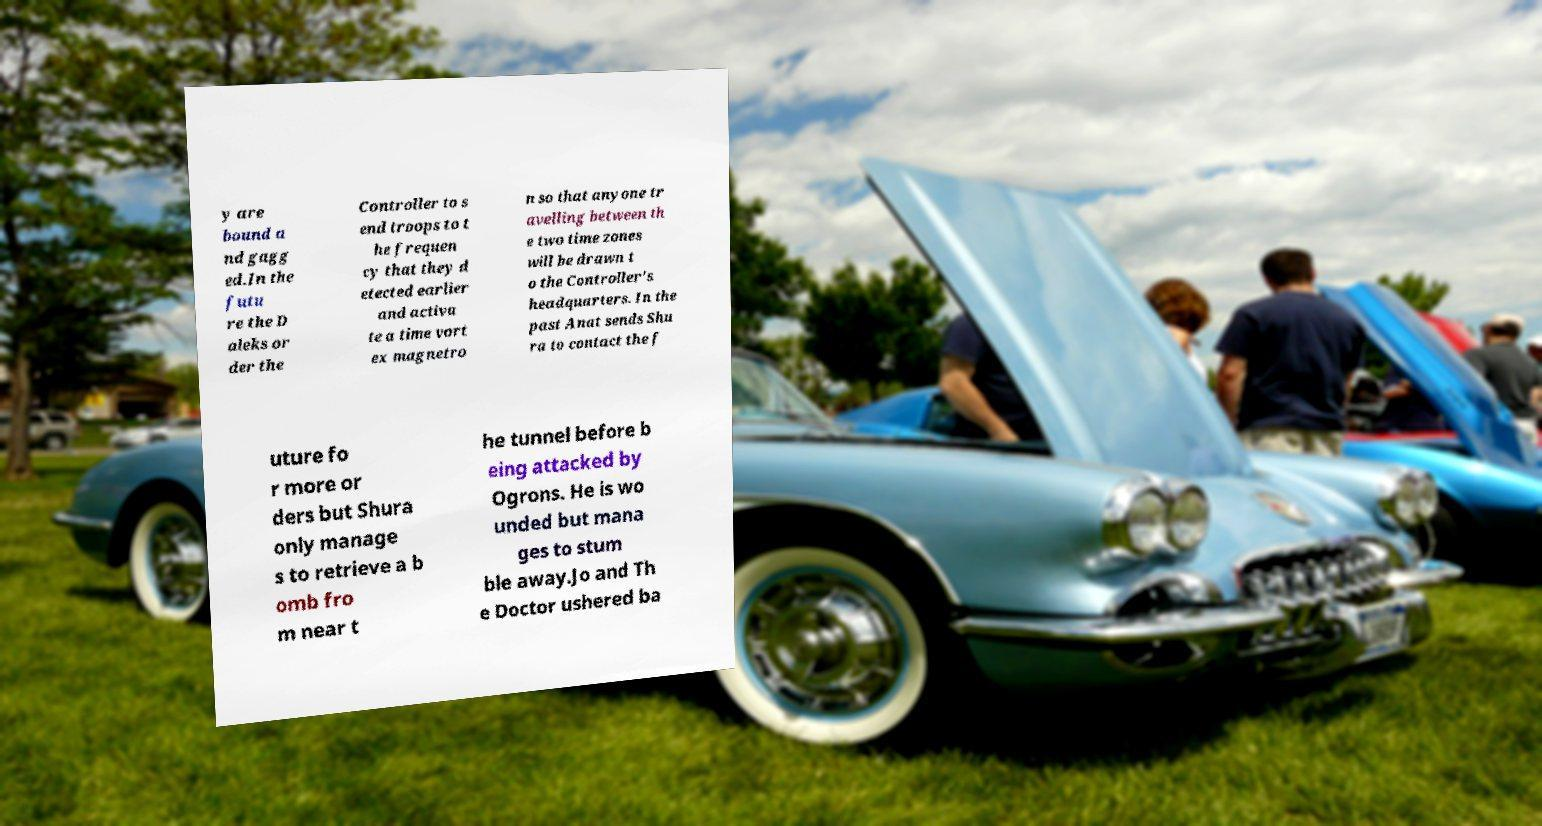What messages or text are displayed in this image? I need them in a readable, typed format. y are bound a nd gagg ed.In the futu re the D aleks or der the Controller to s end troops to t he frequen cy that they d etected earlier and activa te a time vort ex magnetro n so that anyone tr avelling between th e two time zones will be drawn t o the Controller's headquarters. In the past Anat sends Shu ra to contact the f uture fo r more or ders but Shura only manage s to retrieve a b omb fro m near t he tunnel before b eing attacked by Ogrons. He is wo unded but mana ges to stum ble away.Jo and Th e Doctor ushered ba 